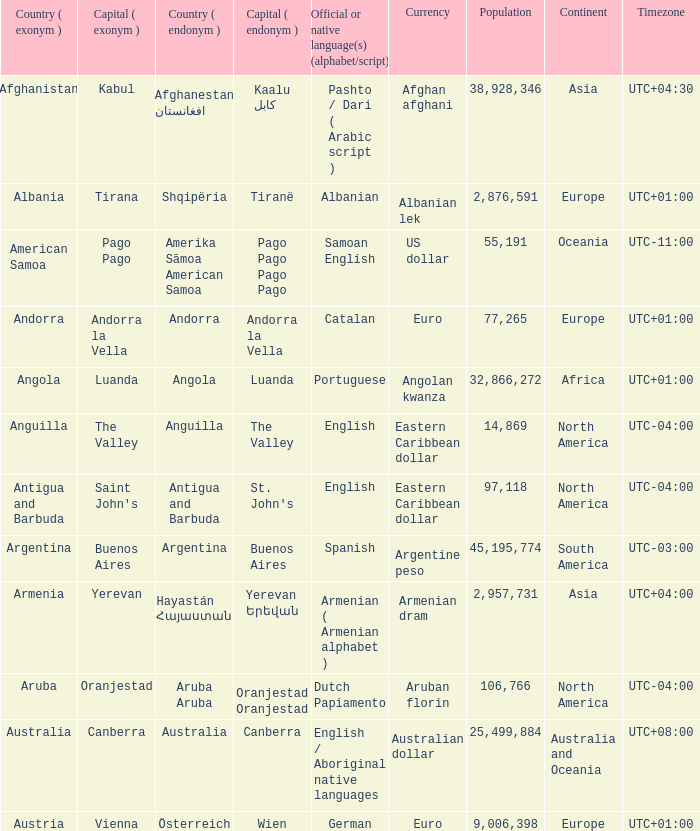What is the English name of the country whose official native language is Dutch Papiamento? Aruba. 